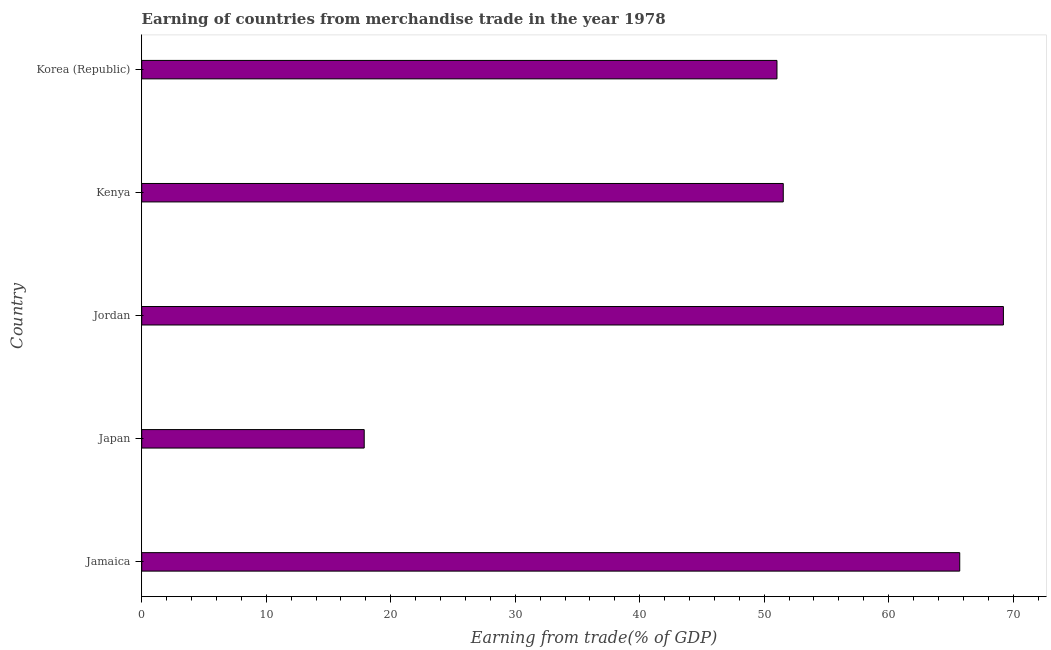Does the graph contain any zero values?
Your answer should be compact. No. Does the graph contain grids?
Your answer should be very brief. No. What is the title of the graph?
Provide a succinct answer. Earning of countries from merchandise trade in the year 1978. What is the label or title of the X-axis?
Keep it short and to the point. Earning from trade(% of GDP). What is the label or title of the Y-axis?
Ensure brevity in your answer.  Country. What is the earning from merchandise trade in Kenya?
Give a very brief answer. 51.53. Across all countries, what is the maximum earning from merchandise trade?
Offer a very short reply. 69.22. Across all countries, what is the minimum earning from merchandise trade?
Your response must be concise. 17.87. In which country was the earning from merchandise trade maximum?
Give a very brief answer. Jordan. In which country was the earning from merchandise trade minimum?
Provide a succinct answer. Japan. What is the sum of the earning from merchandise trade?
Your answer should be compact. 255.35. What is the difference between the earning from merchandise trade in Jamaica and Jordan?
Ensure brevity in your answer.  -3.51. What is the average earning from merchandise trade per country?
Give a very brief answer. 51.07. What is the median earning from merchandise trade?
Offer a terse response. 51.53. In how many countries, is the earning from merchandise trade greater than 30 %?
Your answer should be very brief. 4. What is the ratio of the earning from merchandise trade in Jordan to that in Korea (Republic)?
Provide a succinct answer. 1.36. Is the earning from merchandise trade in Jordan less than that in Korea (Republic)?
Offer a terse response. No. What is the difference between the highest and the second highest earning from merchandise trade?
Ensure brevity in your answer.  3.51. What is the difference between the highest and the lowest earning from merchandise trade?
Your response must be concise. 51.34. In how many countries, is the earning from merchandise trade greater than the average earning from merchandise trade taken over all countries?
Keep it short and to the point. 3. What is the difference between two consecutive major ticks on the X-axis?
Your response must be concise. 10. What is the Earning from trade(% of GDP) of Jamaica?
Your answer should be very brief. 65.71. What is the Earning from trade(% of GDP) in Japan?
Provide a succinct answer. 17.87. What is the Earning from trade(% of GDP) in Jordan?
Your response must be concise. 69.22. What is the Earning from trade(% of GDP) in Kenya?
Give a very brief answer. 51.53. What is the Earning from trade(% of GDP) in Korea (Republic)?
Your response must be concise. 51.03. What is the difference between the Earning from trade(% of GDP) in Jamaica and Japan?
Ensure brevity in your answer.  47.83. What is the difference between the Earning from trade(% of GDP) in Jamaica and Jordan?
Give a very brief answer. -3.51. What is the difference between the Earning from trade(% of GDP) in Jamaica and Kenya?
Offer a terse response. 14.17. What is the difference between the Earning from trade(% of GDP) in Jamaica and Korea (Republic)?
Your response must be concise. 14.68. What is the difference between the Earning from trade(% of GDP) in Japan and Jordan?
Offer a very short reply. -51.34. What is the difference between the Earning from trade(% of GDP) in Japan and Kenya?
Provide a short and direct response. -33.66. What is the difference between the Earning from trade(% of GDP) in Japan and Korea (Republic)?
Your answer should be compact. -33.15. What is the difference between the Earning from trade(% of GDP) in Jordan and Kenya?
Provide a short and direct response. 17.68. What is the difference between the Earning from trade(% of GDP) in Jordan and Korea (Republic)?
Keep it short and to the point. 18.19. What is the difference between the Earning from trade(% of GDP) in Kenya and Korea (Republic)?
Offer a terse response. 0.51. What is the ratio of the Earning from trade(% of GDP) in Jamaica to that in Japan?
Your answer should be compact. 3.68. What is the ratio of the Earning from trade(% of GDP) in Jamaica to that in Jordan?
Your answer should be very brief. 0.95. What is the ratio of the Earning from trade(% of GDP) in Jamaica to that in Kenya?
Keep it short and to the point. 1.27. What is the ratio of the Earning from trade(% of GDP) in Jamaica to that in Korea (Republic)?
Keep it short and to the point. 1.29. What is the ratio of the Earning from trade(% of GDP) in Japan to that in Jordan?
Provide a short and direct response. 0.26. What is the ratio of the Earning from trade(% of GDP) in Japan to that in Kenya?
Provide a succinct answer. 0.35. What is the ratio of the Earning from trade(% of GDP) in Jordan to that in Kenya?
Your answer should be compact. 1.34. What is the ratio of the Earning from trade(% of GDP) in Jordan to that in Korea (Republic)?
Make the answer very short. 1.36. 